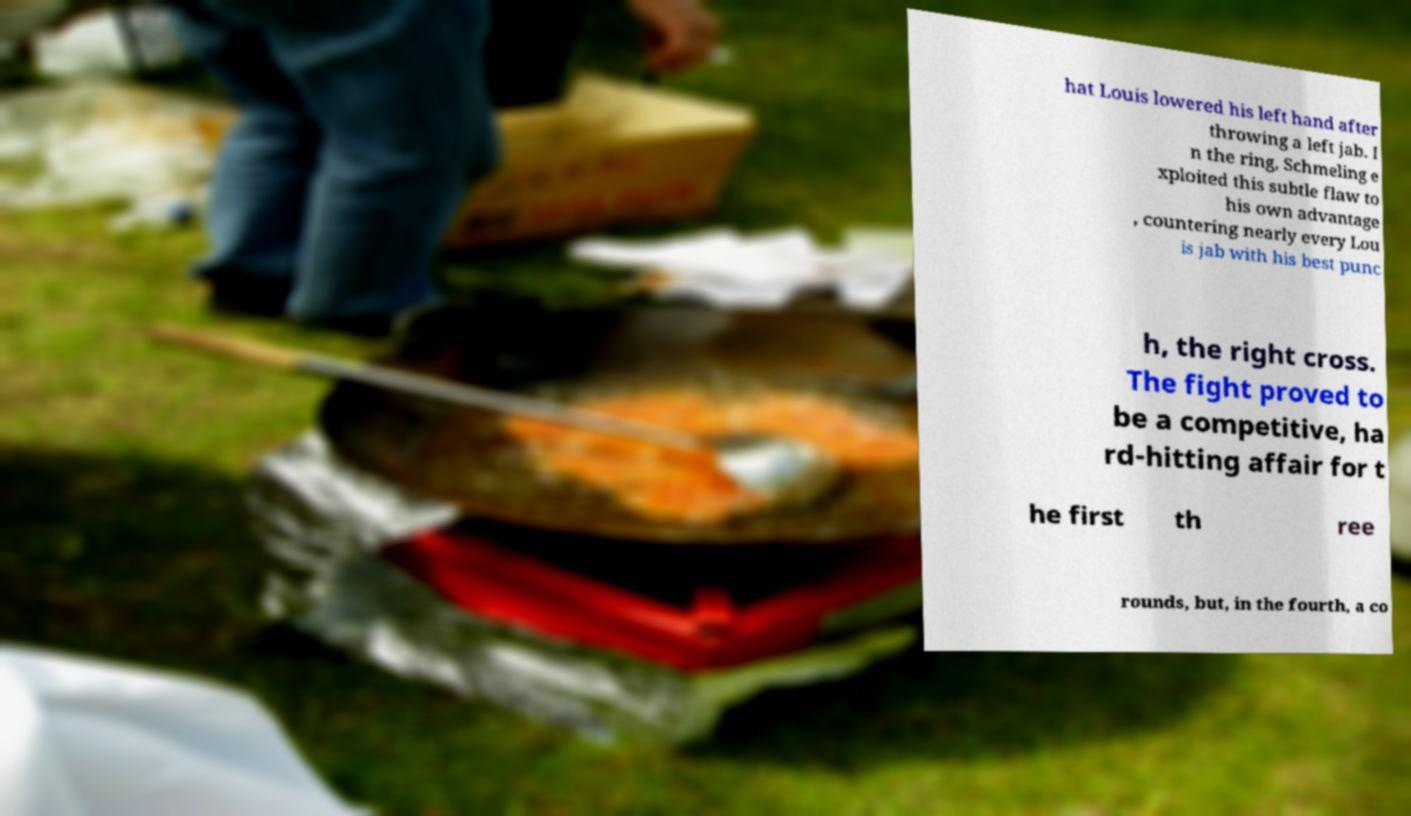Please identify and transcribe the text found in this image. hat Louis lowered his left hand after throwing a left jab. I n the ring, Schmeling e xploited this subtle flaw to his own advantage , countering nearly every Lou is jab with his best punc h, the right cross. The fight proved to be a competitive, ha rd-hitting affair for t he first th ree rounds, but, in the fourth, a co 